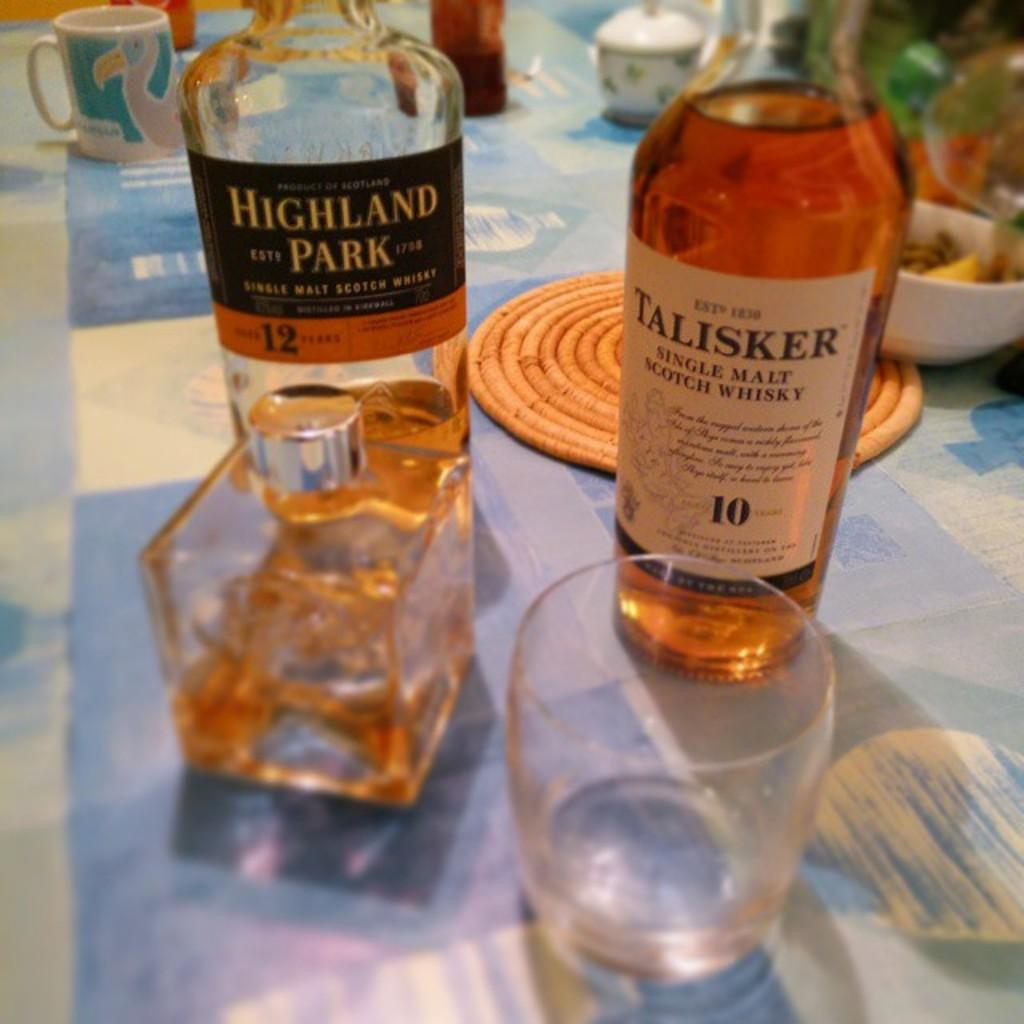Provide a one-sentence caption for the provided image. A bottle of Talisker single malt whisky sits next to a different whisky bottle. 